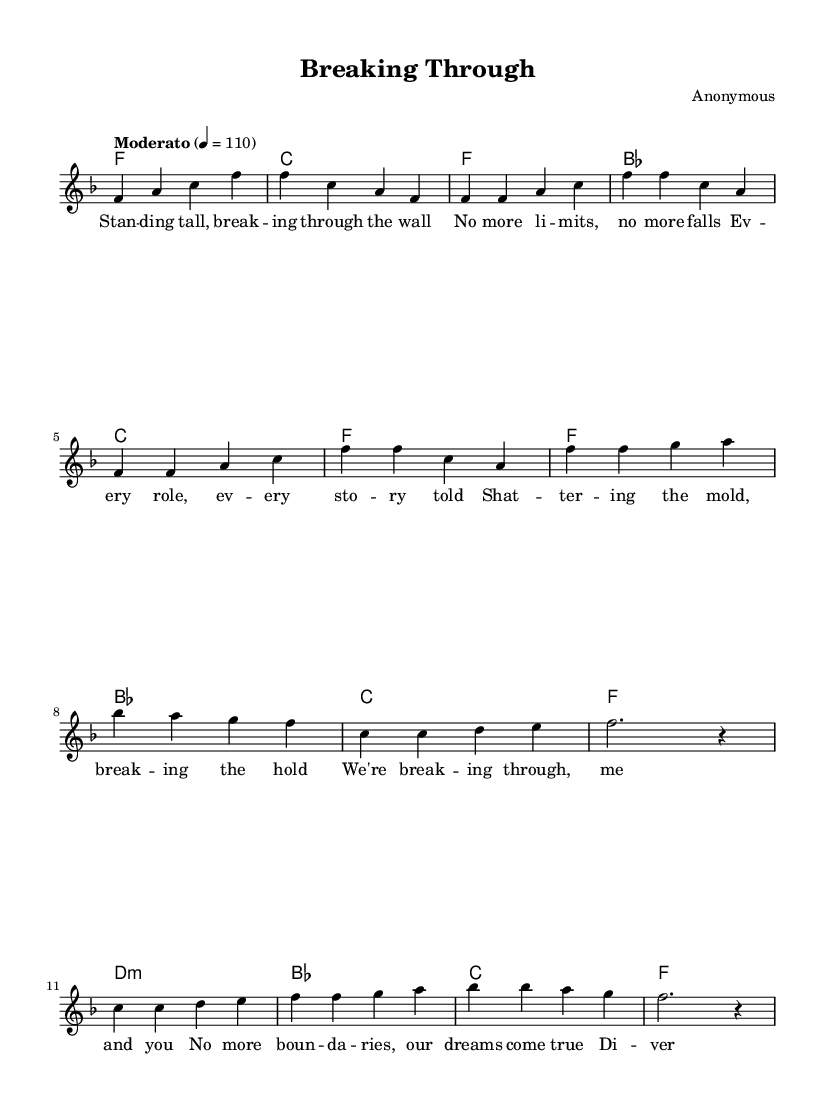What is the key signature of this music? The key signature is F major, which has one flat (B flat). This can be seen at the beginning of the sheet music above the staff where the F major symbol is indicated.
Answer: F major What is the time signature of the piece? The time signature displayed at the beginning of the sheet music is 4/4, which means there are four beats in each measure and the quarter note receives one beat. This is typically notated in the first few measures of the score.
Answer: 4/4 What is the tempo marking of the music? The tempo marking at the beginning indicates "Moderato" and provides a tempo of 110 beats per minute. This information can be found in the tempo indication that appears at the start of the score.
Answer: Moderato How many measures are in the verse? The verse section consists of 8 measures, as indicated by the notation provided for the verse and counting each measure in the melody part. This can be verified by visually inspecting the music notation under the verse lyrics.
Answer: 8 Which section features the lyrics "We're breaking through, me and you"? This line appears in the chorus section of the song, which is distinct from the verses. This can be identified by looking at the placement of the lyrics in relation to the melody that follows.
Answer: Chorus What type of chords are used in the bridge? The bridge uses minor chords, starting with D minor and followed by B flat and C major. A careful assessment of the chord mode section allows for identification of the type of chords utilized in this part of the song.
Answer: Minor What is the central theme conveyed in the lyrics? The central theme conveyed in the lyrics revolves around unity, diversity, and breaking barriers, emphasizing empowerment and overcoming challenges together. Analyzing the lyrics provides insight into the message of the song, particularly in the chorus and verses.
Answer: Unity and empowerment 